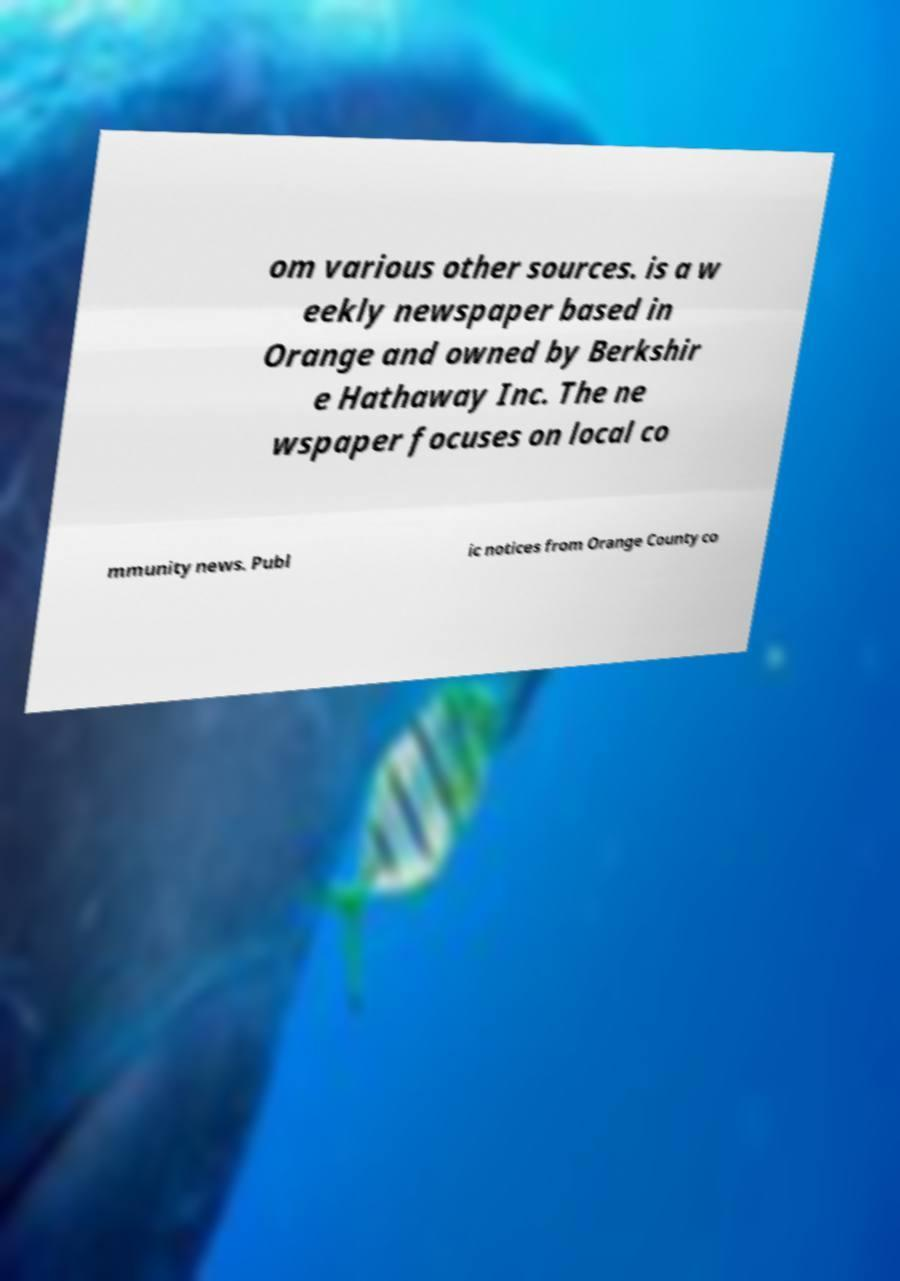What messages or text are displayed in this image? I need them in a readable, typed format. om various other sources. is a w eekly newspaper based in Orange and owned by Berkshir e Hathaway Inc. The ne wspaper focuses on local co mmunity news. Publ ic notices from Orange County co 